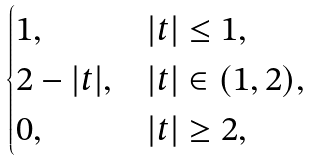Convert formula to latex. <formula><loc_0><loc_0><loc_500><loc_500>\begin{cases} 1 , & | t | \leq 1 , \\ 2 - | t | , & | t | \in ( 1 , 2 ) , \\ 0 , & | t | \geq 2 , \end{cases}</formula> 